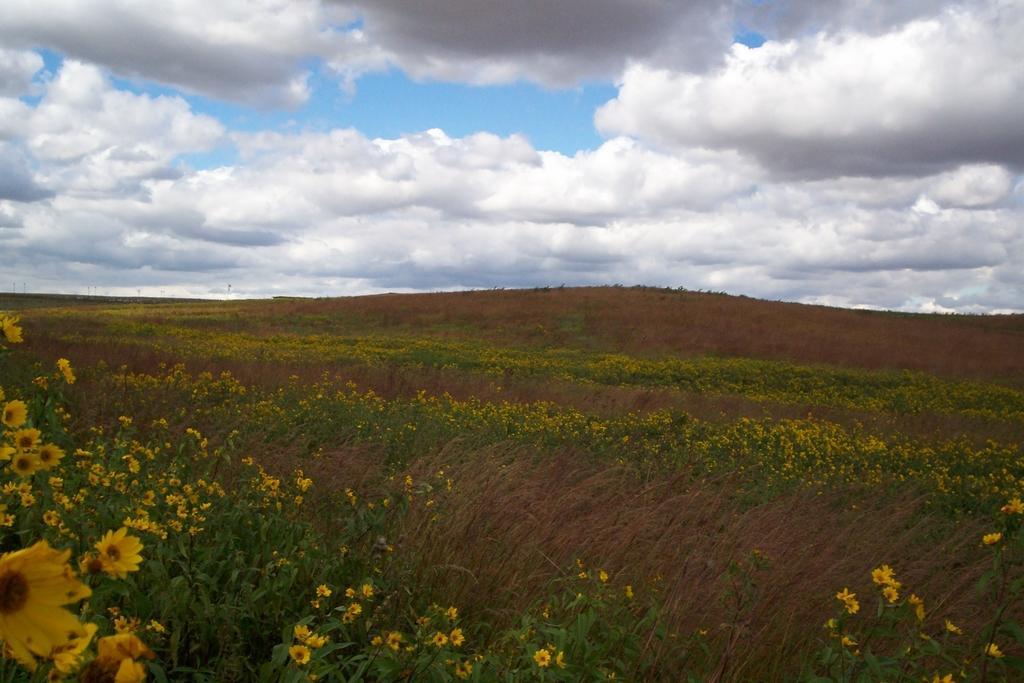Please provide a concise description of this image. There is a field of a yellow color flowers at the bottom of this image, and there is a cloudy sky at the top of this image. 